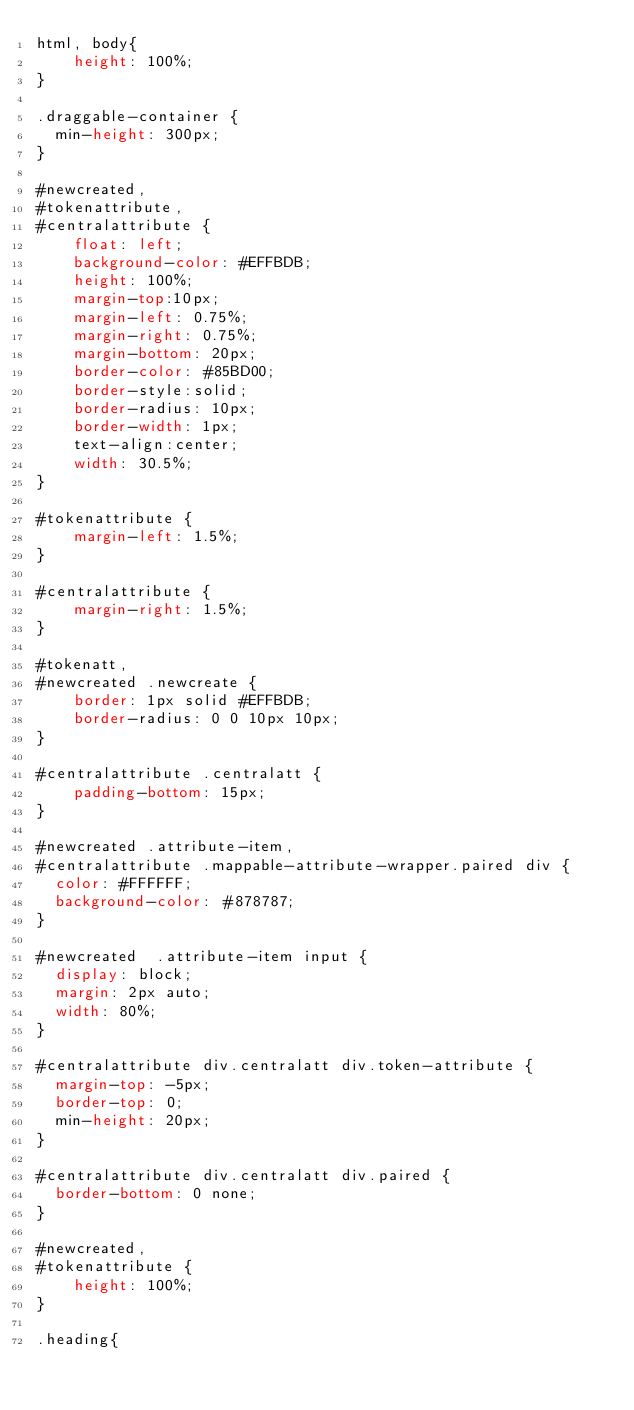<code> <loc_0><loc_0><loc_500><loc_500><_CSS_>html, body{
    height: 100%;
}

.draggable-container {
	min-height: 300px;
}

#newcreated,
#tokenattribute,
#centralattribute {
    float: left;
    background-color: #EFFBDB;
    height: 100%;
    margin-top:10px;
    margin-left: 0.75%;
    margin-right: 0.75%;
    margin-bottom: 20px;
    border-color: #85BD00;
    border-style:solid;
    border-radius: 10px;
    border-width: 1px;
    text-align:center;
    width: 30.5%;
}

#tokenattribute {
    margin-left: 1.5%;
}

#centralattribute {
    margin-right: 1.5%;
}

#tokenatt,
#newcreated .newcreate {
    border: 1px solid #EFFBDB;
    border-radius: 0 0 10px 10px;
}

#centralattribute .centralatt {
    padding-bottom: 15px;
}

#newcreated .attribute-item,
#centralattribute .mappable-attribute-wrapper.paired div {
	color: #FFFFFF;
	background-color: #878787;
}

#newcreated  .attribute-item input {
	display: block;
	margin: 2px auto;
	width: 80%;
}

#centralattribute div.centralatt div.token-attribute {
	margin-top: -5px;
	border-top: 0;
	min-height: 20px;
}

#centralattribute div.centralatt div.paired {
	border-bottom: 0 none;
}

#newcreated, 
#tokenattribute {
    height: 100%;
}

.heading{</code> 